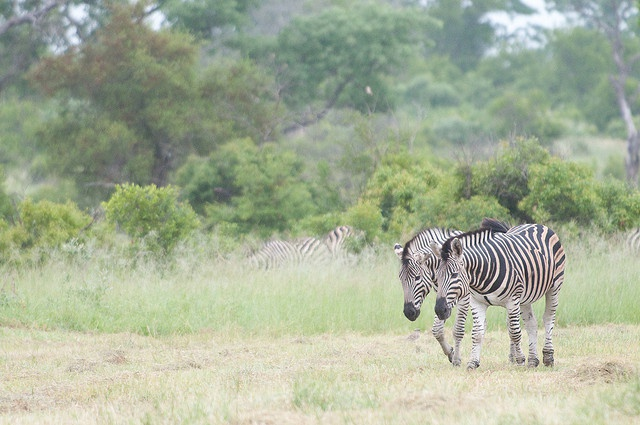Describe the objects in this image and their specific colors. I can see zebra in gray, lightgray, darkgray, and beige tones, zebra in gray, darkgray, and lightgray tones, zebra in gray, lightgray, and darkgray tones, zebra in gray, darkgray, and lightgray tones, and zebra in gray, lightgray, and darkgray tones in this image. 